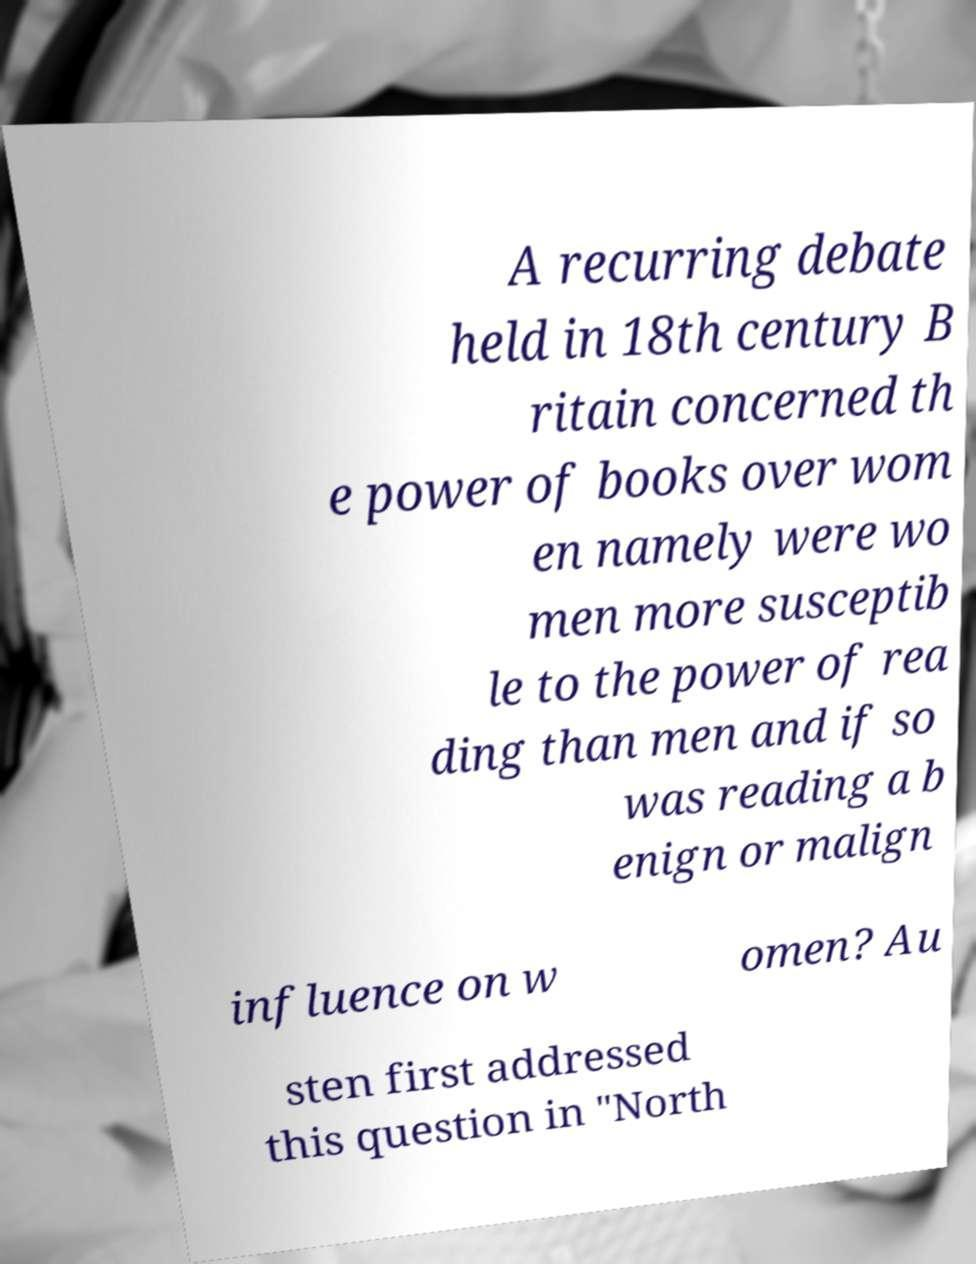Can you read and provide the text displayed in the image?This photo seems to have some interesting text. Can you extract and type it out for me? A recurring debate held in 18th century B ritain concerned th e power of books over wom en namely were wo men more susceptib le to the power of rea ding than men and if so was reading a b enign or malign influence on w omen? Au sten first addressed this question in "North 